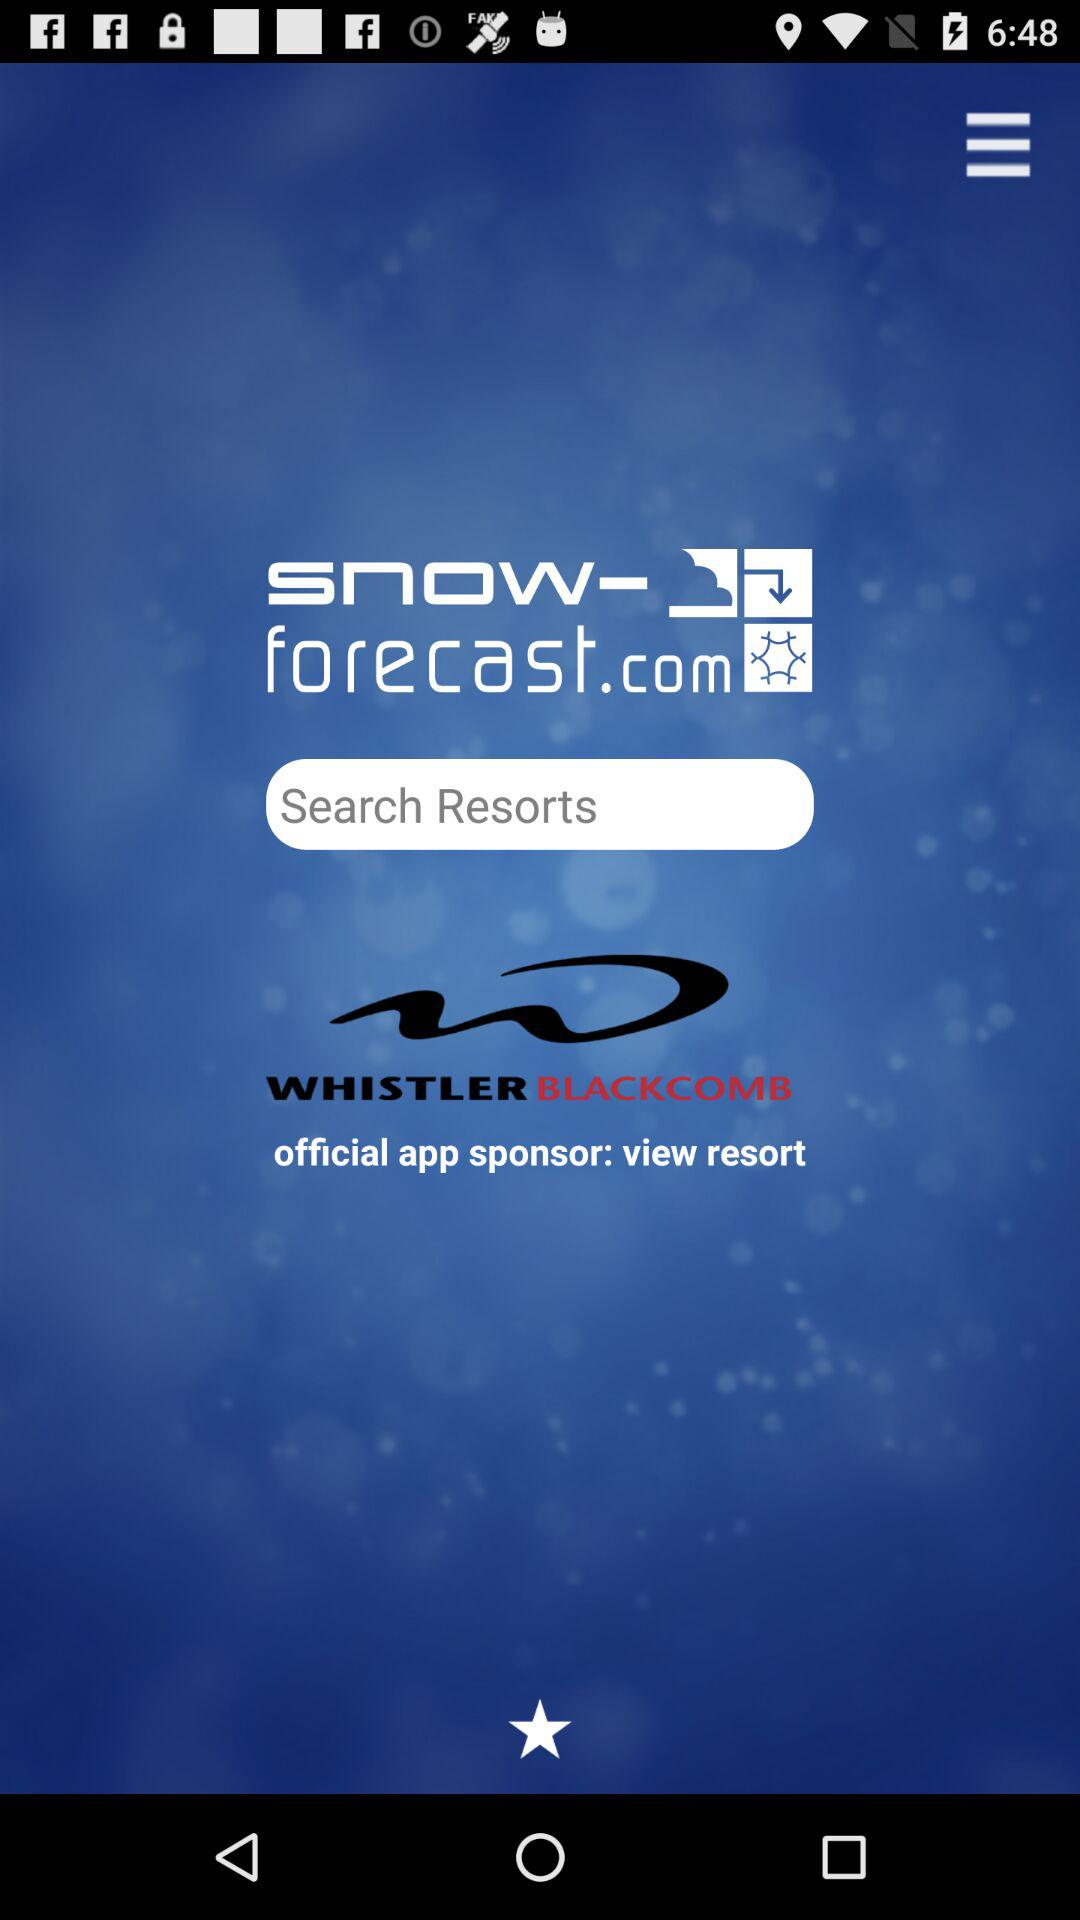What is the name of the application? The name of the application is "snow-forecast.com". 